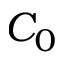Convert formula to latex. <formula><loc_0><loc_0><loc_500><loc_500>C _ { 0 }</formula> 